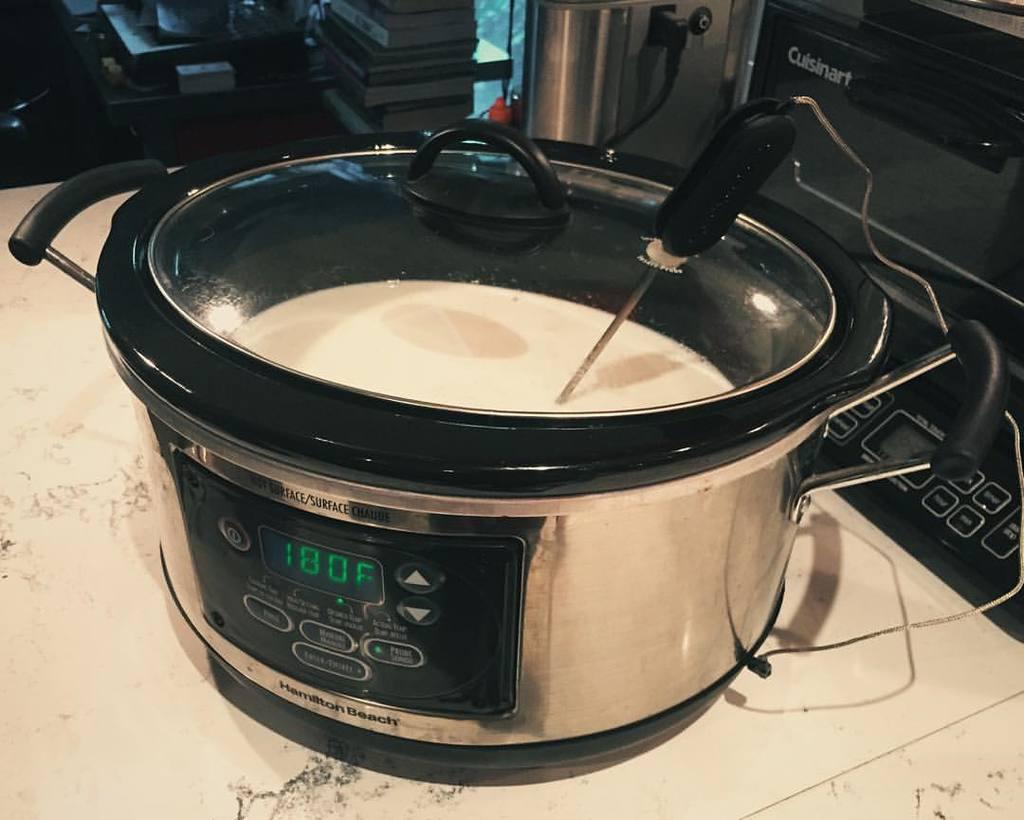Who manufactured the appliance behind the pot?
Provide a succinct answer. Cuisinart. 